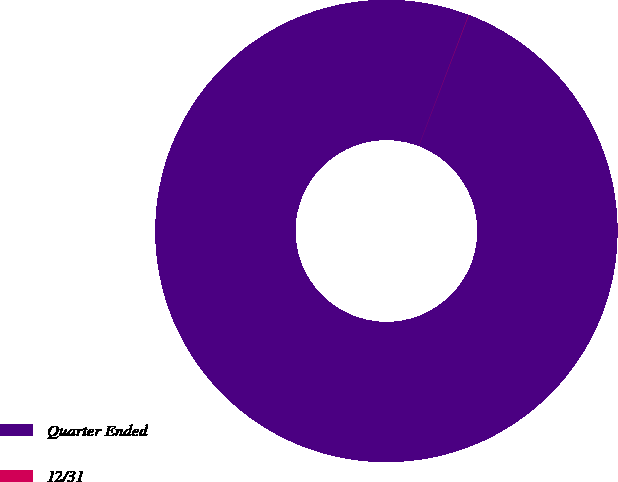Convert chart. <chart><loc_0><loc_0><loc_500><loc_500><pie_chart><fcel>Quarter Ended<fcel>12/31<nl><fcel>99.98%<fcel>0.02%<nl></chart> 